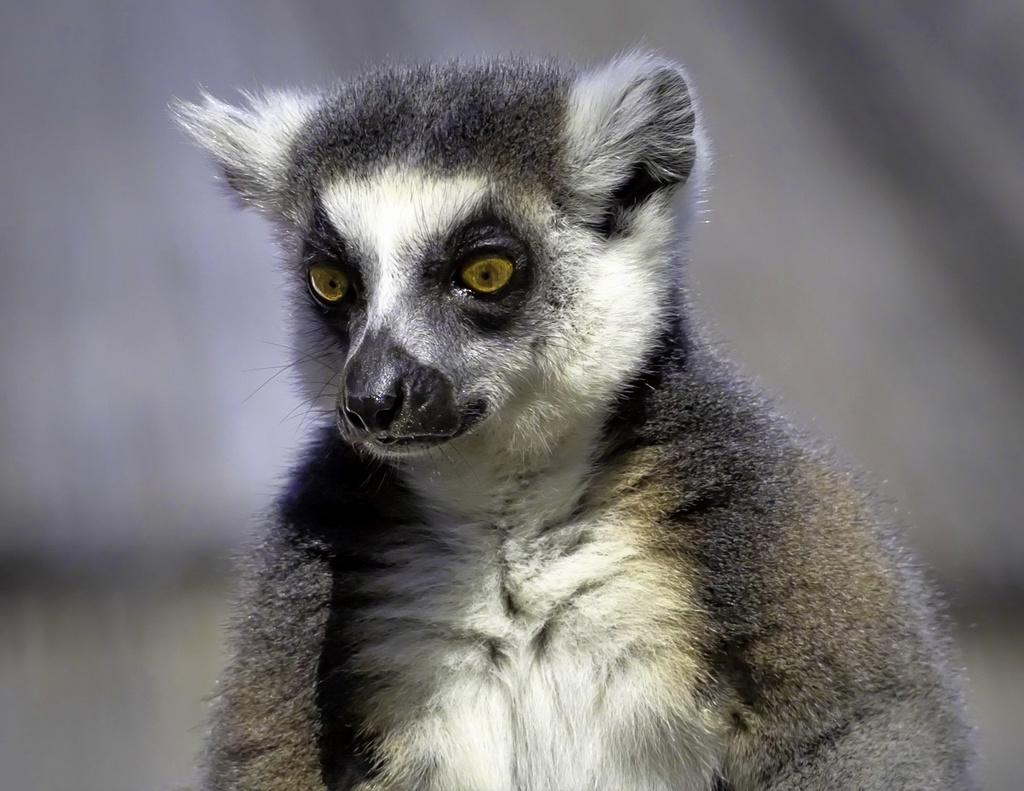What is the main subject in the foreground of the image? There is an animal in the foreground of the image. Can you describe the background of the image? The background of the image is blurred. How does the arm of the animal appear in the image? There is no mention of an arm in the image, as it features an animal without any visible limbs. 